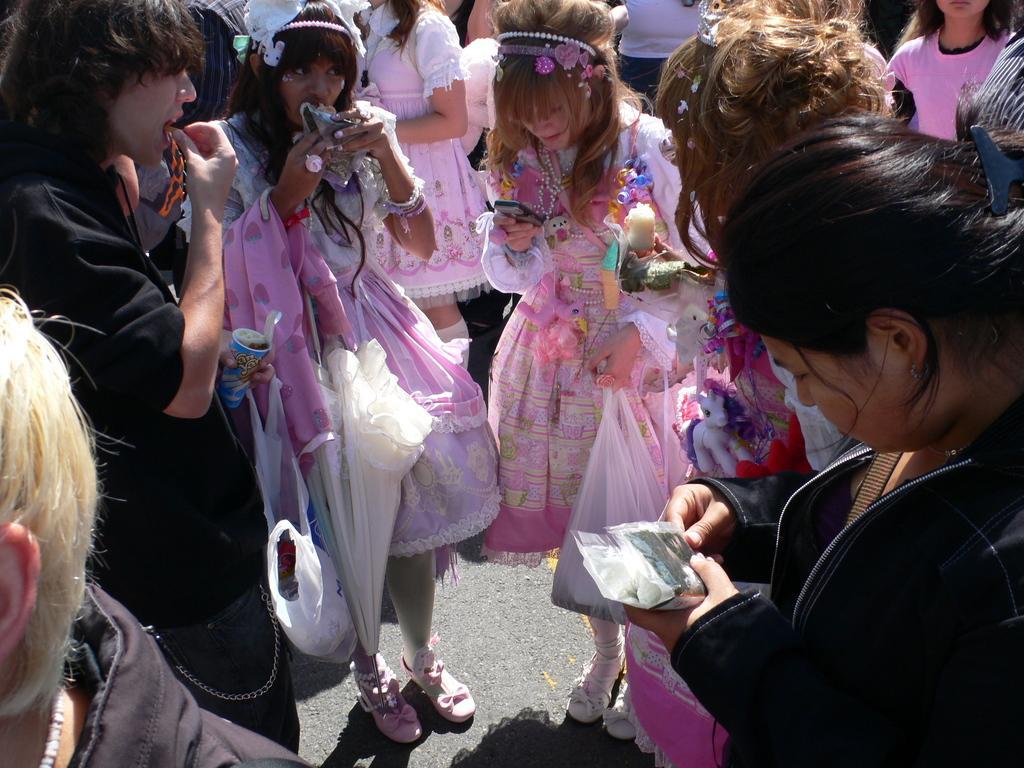In one or two sentences, can you explain what this image depicts? In this image we can see many people. There are many people holding the objects in their hands. 